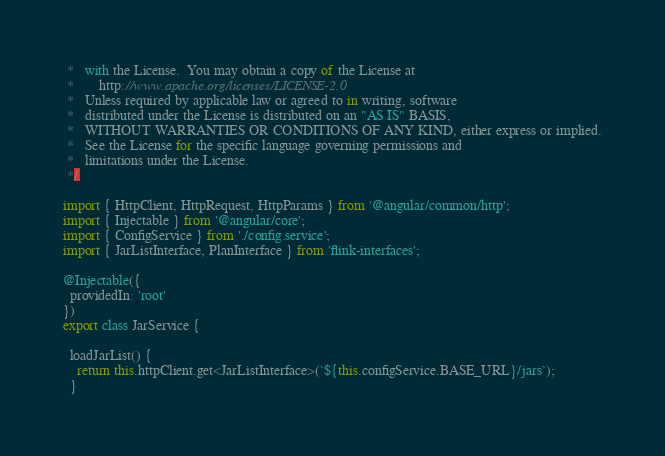Convert code to text. <code><loc_0><loc_0><loc_500><loc_500><_TypeScript_> *   with the License.  You may obtain a copy of the License at
 *       http://www.apache.org/licenses/LICENSE-2.0
 *   Unless required by applicable law or agreed to in writing, software
 *   distributed under the License is distributed on an "AS IS" BASIS,
 *   WITHOUT WARRANTIES OR CONDITIONS OF ANY KIND, either express or implied.
 *   See the License for the specific language governing permissions and
 *   limitations under the License.
 */

import { HttpClient, HttpRequest, HttpParams } from '@angular/common/http';
import { Injectable } from '@angular/core';
import { ConfigService } from './config.service';
import { JarListInterface, PlanInterface } from 'flink-interfaces';

@Injectable({
  providedIn: 'root'
})
export class JarService {

  loadJarList() {
    return this.httpClient.get<JarListInterface>(`${this.configService.BASE_URL}/jars`);
  }
</code> 